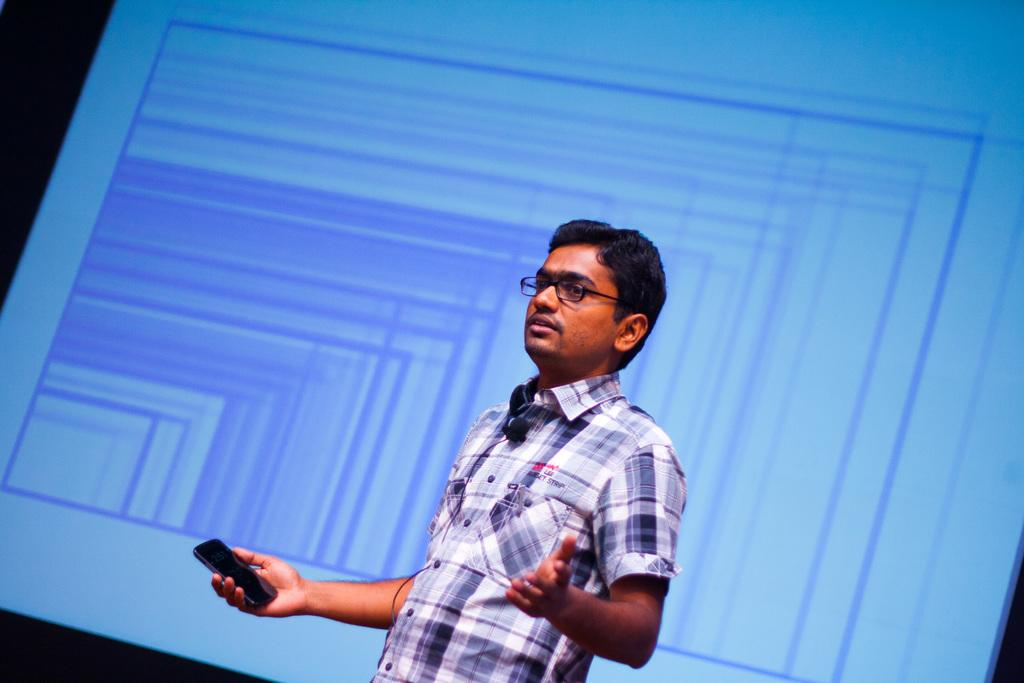Who is the main subject in the image? There is a man in the image. What is the man wearing? The man is wearing spectacles. What is the man holding in his hand? The man is holding a mobile in his hand. What is visible behind the man? There is a screen visible at the back of the man. How would you describe the lighting in the image? The background of the image is dark. What type of plant is growing on the man's head in the image? There is no plant growing on the man's head in the image. What trick is the man performing with the knife in the image? There is no knife present in the image, and the man is not performing any tricks. 